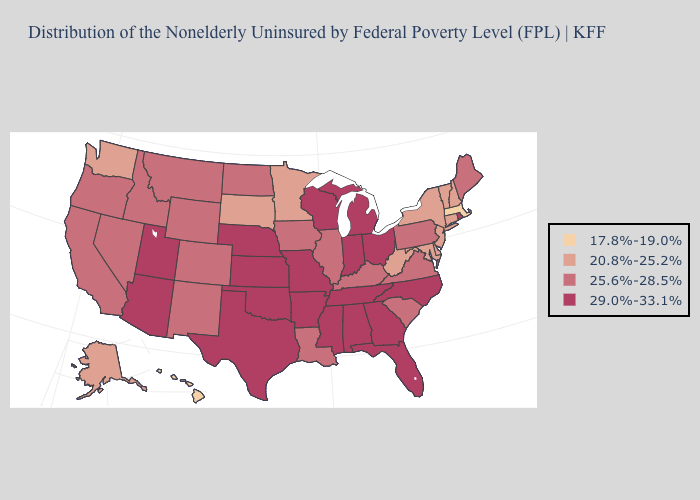How many symbols are there in the legend?
Give a very brief answer. 4. Name the states that have a value in the range 20.8%-25.2%?
Give a very brief answer. Alaska, Connecticut, Delaware, Maryland, Minnesota, New Hampshire, New Jersey, New York, South Dakota, Vermont, Washington, West Virginia. Name the states that have a value in the range 29.0%-33.1%?
Keep it brief. Alabama, Arizona, Arkansas, Florida, Georgia, Indiana, Kansas, Michigan, Mississippi, Missouri, Nebraska, North Carolina, Ohio, Oklahoma, Rhode Island, Tennessee, Texas, Utah, Wisconsin. Does Virginia have the highest value in the USA?
Give a very brief answer. No. Does the map have missing data?
Answer briefly. No. What is the value of North Carolina?
Short answer required. 29.0%-33.1%. Which states have the highest value in the USA?
Write a very short answer. Alabama, Arizona, Arkansas, Florida, Georgia, Indiana, Kansas, Michigan, Mississippi, Missouri, Nebraska, North Carolina, Ohio, Oklahoma, Rhode Island, Tennessee, Texas, Utah, Wisconsin. What is the lowest value in the West?
Short answer required. 17.8%-19.0%. What is the highest value in the South ?
Quick response, please. 29.0%-33.1%. What is the highest value in states that border Kentucky?
Give a very brief answer. 29.0%-33.1%. Does Michigan have the same value as Minnesota?
Write a very short answer. No. Among the states that border Oklahoma , does Arkansas have the lowest value?
Quick response, please. No. Name the states that have a value in the range 17.8%-19.0%?
Write a very short answer. Hawaii, Massachusetts. Does Louisiana have the highest value in the South?
Write a very short answer. No. How many symbols are there in the legend?
Quick response, please. 4. 